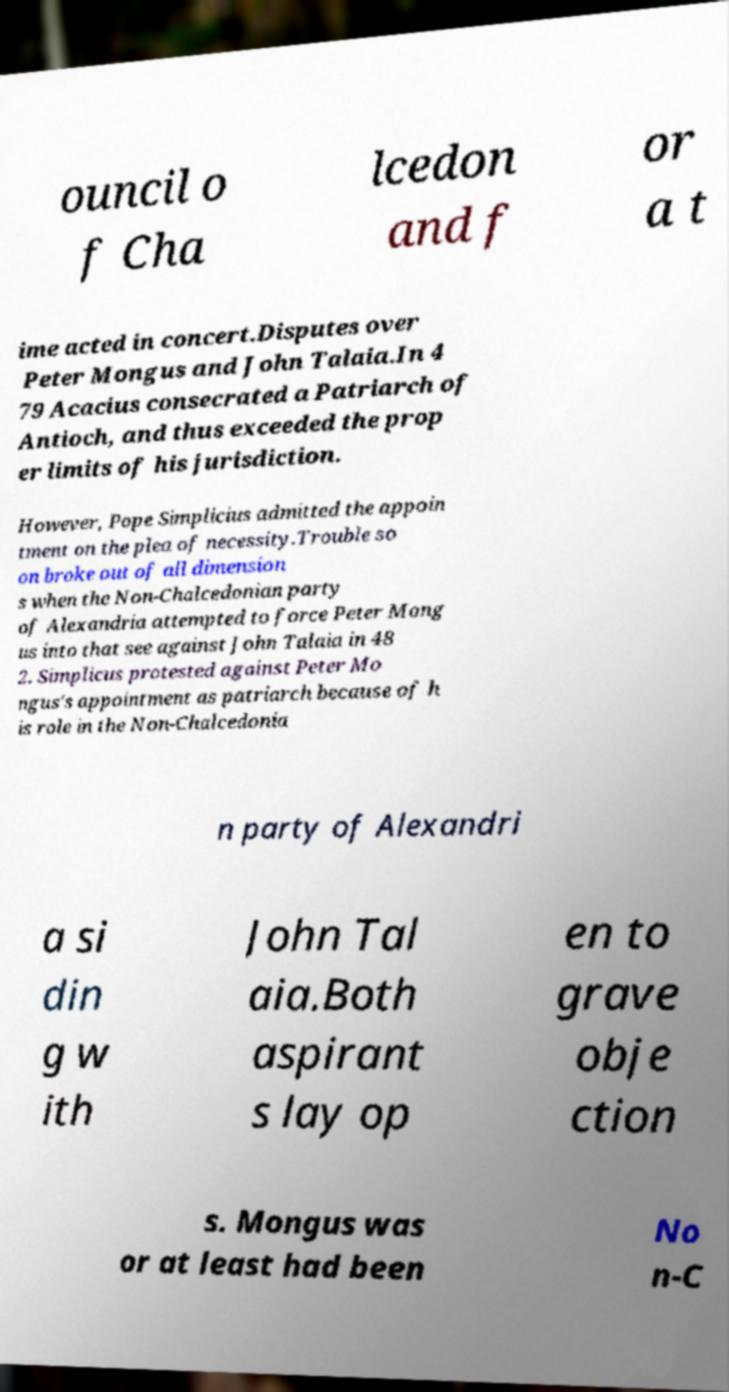Can you read and provide the text displayed in the image?This photo seems to have some interesting text. Can you extract and type it out for me? ouncil o f Cha lcedon and f or a t ime acted in concert.Disputes over Peter Mongus and John Talaia.In 4 79 Acacius consecrated a Patriarch of Antioch, and thus exceeded the prop er limits of his jurisdiction. However, Pope Simplicius admitted the appoin tment on the plea of necessity.Trouble so on broke out of all dimension s when the Non-Chalcedonian party of Alexandria attempted to force Peter Mong us into that see against John Talaia in 48 2. Simplicus protested against Peter Mo ngus's appointment as patriarch because of h is role in the Non-Chalcedonia n party of Alexandri a si din g w ith John Tal aia.Both aspirant s lay op en to grave obje ction s. Mongus was or at least had been No n-C 